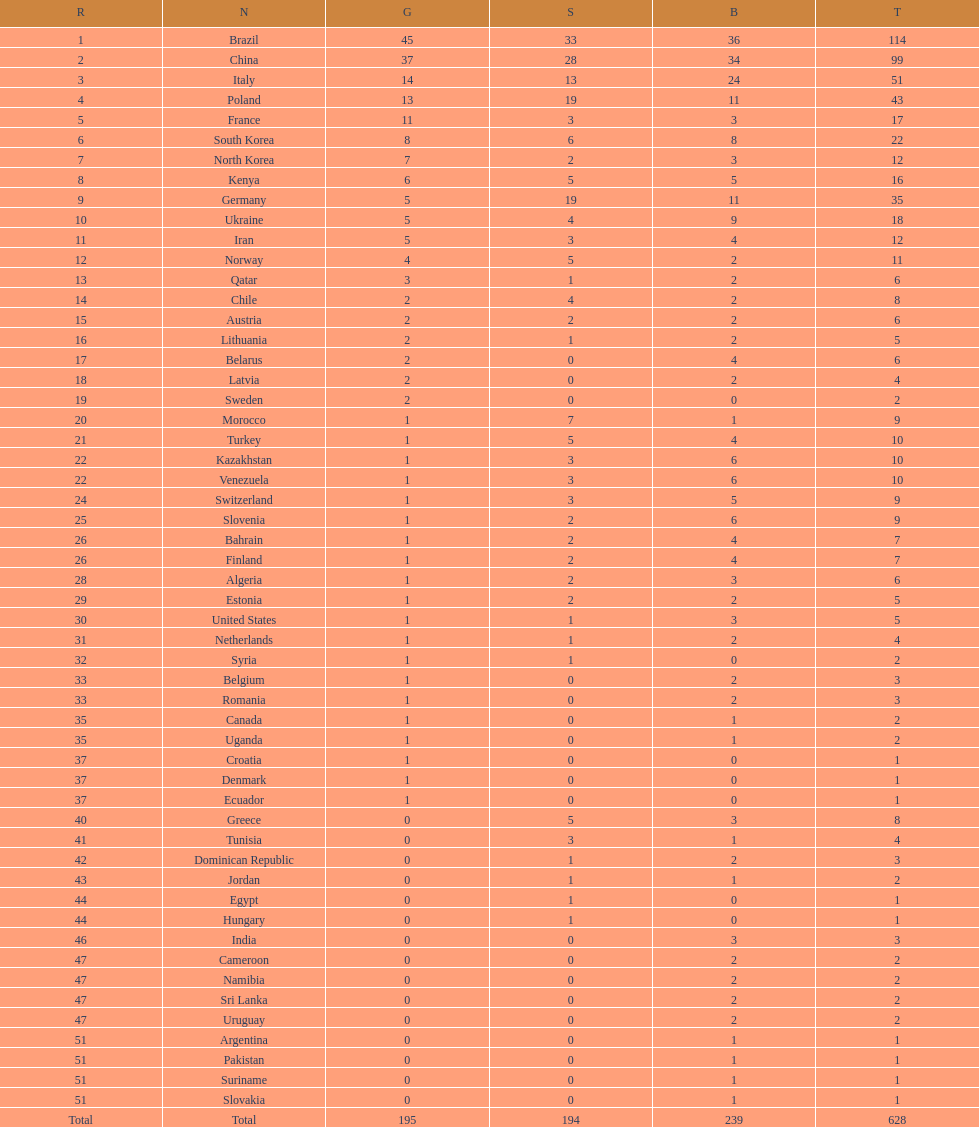Who won more gold medals, brazil or china? Brazil. 